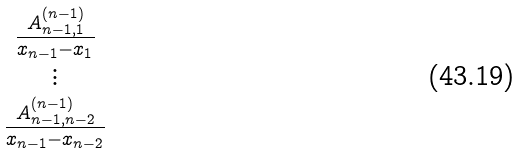Convert formula to latex. <formula><loc_0><loc_0><loc_500><loc_500>\begin{matrix} \frac { A ^ { ( n - 1 ) } _ { n - 1 , 1 } } { x _ { n - 1 } - x _ { 1 } } \\ \vdots \\ \frac { A ^ { ( n - 1 ) } _ { n - 1 , n - 2 } } { x _ { n - 1 } - x _ { n - 2 } } \\ \end{matrix}</formula> 